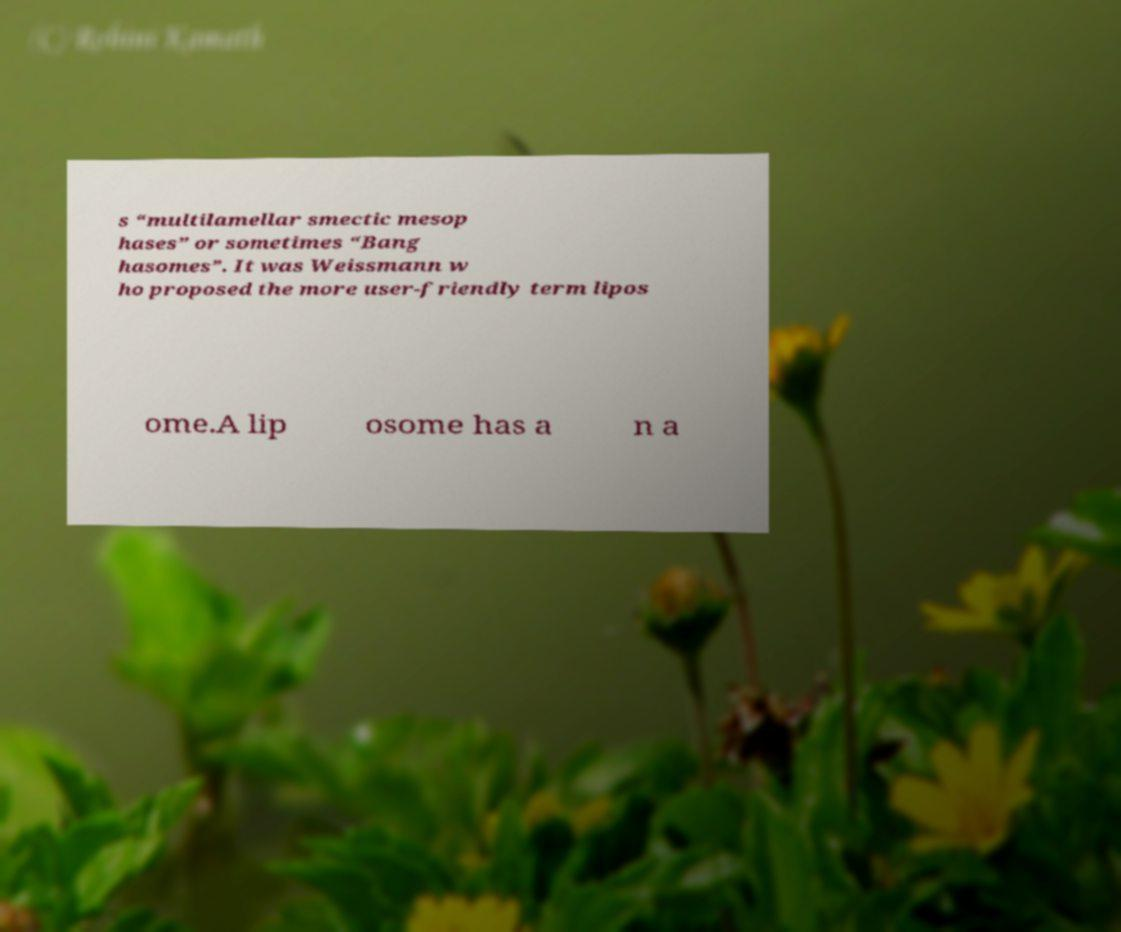Can you accurately transcribe the text from the provided image for me? s “multilamellar smectic mesop hases” or sometimes “Bang hasomes”. It was Weissmann w ho proposed the more user-friendly term lipos ome.A lip osome has a n a 